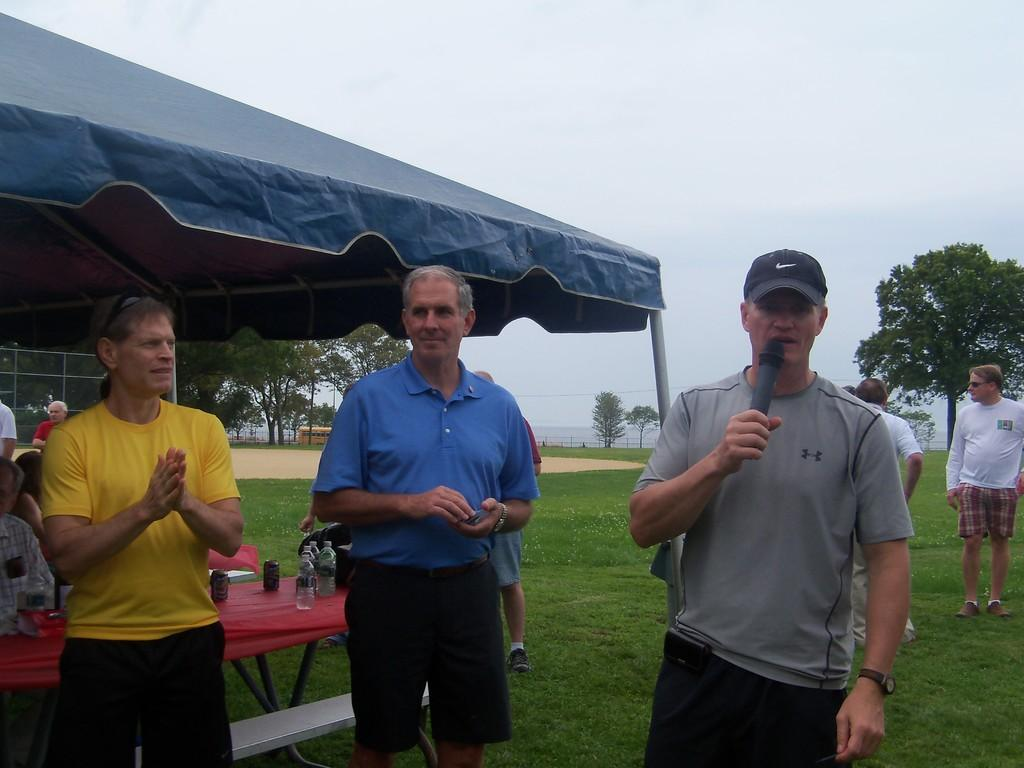Who or what is present in the image? There are people in the image. What type of natural environment is visible in the image? There is grass in the image, which suggests a natural setting. What type of furniture is present in the image? There are tables in the image. What type of vegetation is visible in the image? There are trees in the image. What objects are on the tables in the image? There are bottles on the tables. What is visible at the top of the image? The sky is visible at the top of the image. What type of drug is being traded on the tables in the image? There is no drug present in the image, and no trade is taking place. What type of expansion is visible in the image? There is no expansion visible in the image; it features people, grass, tables, trees, bottles, and the sky. 